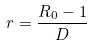<formula> <loc_0><loc_0><loc_500><loc_500>r = \frac { R _ { 0 } - 1 } { D }</formula> 